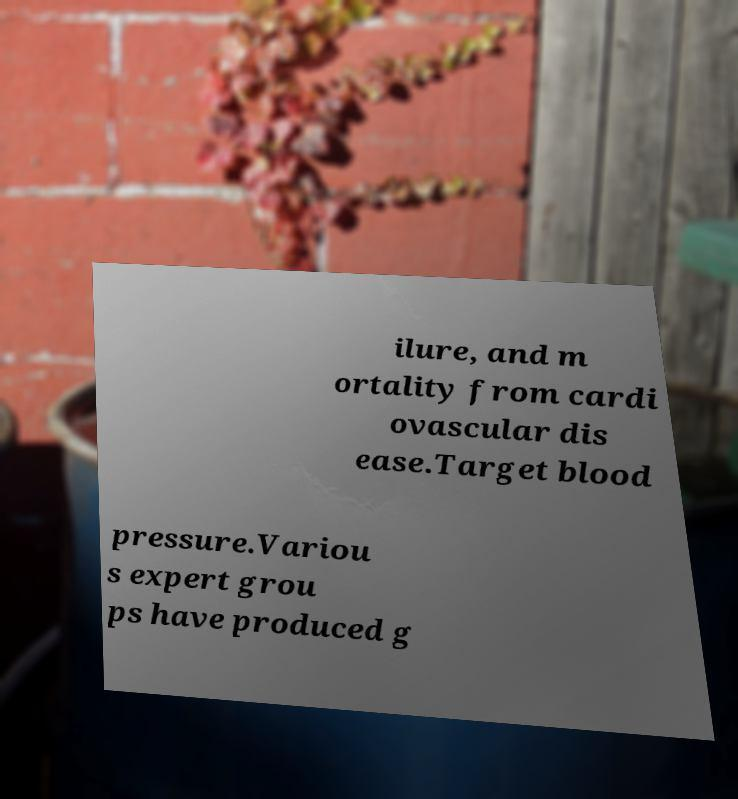I need the written content from this picture converted into text. Can you do that? ilure, and m ortality from cardi ovascular dis ease.Target blood pressure.Variou s expert grou ps have produced g 